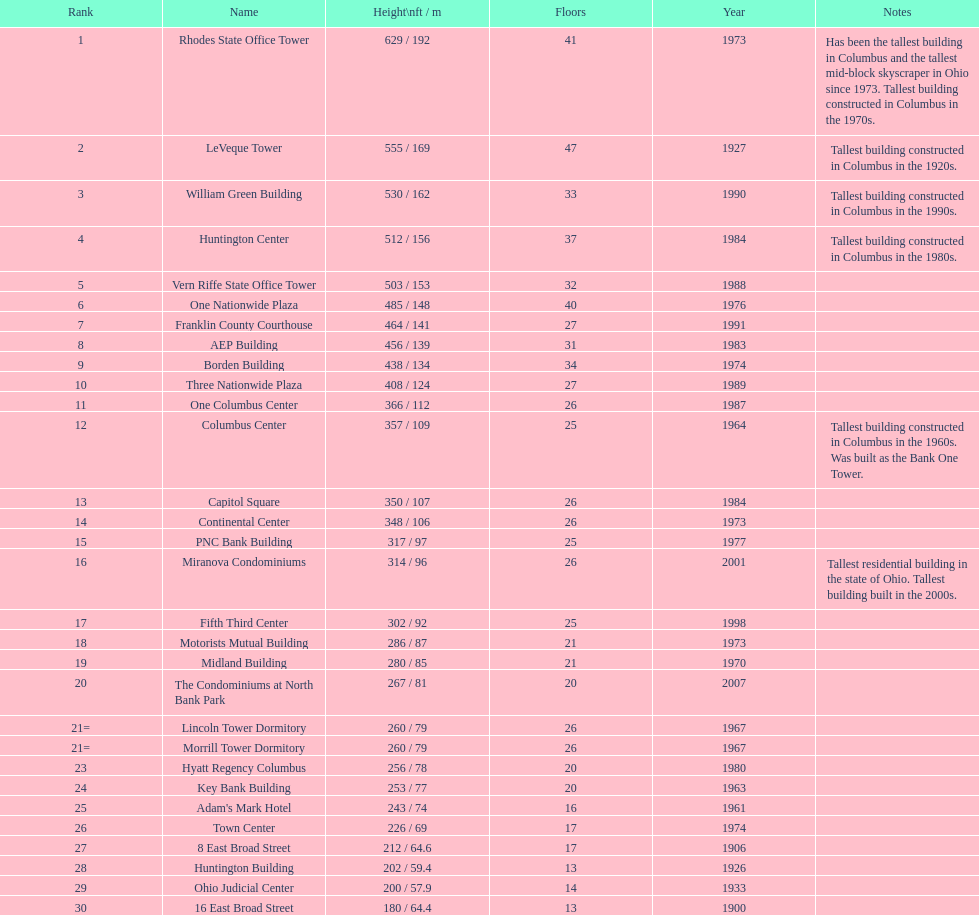How many buildings on this table are taller than 450 feet? 8. 